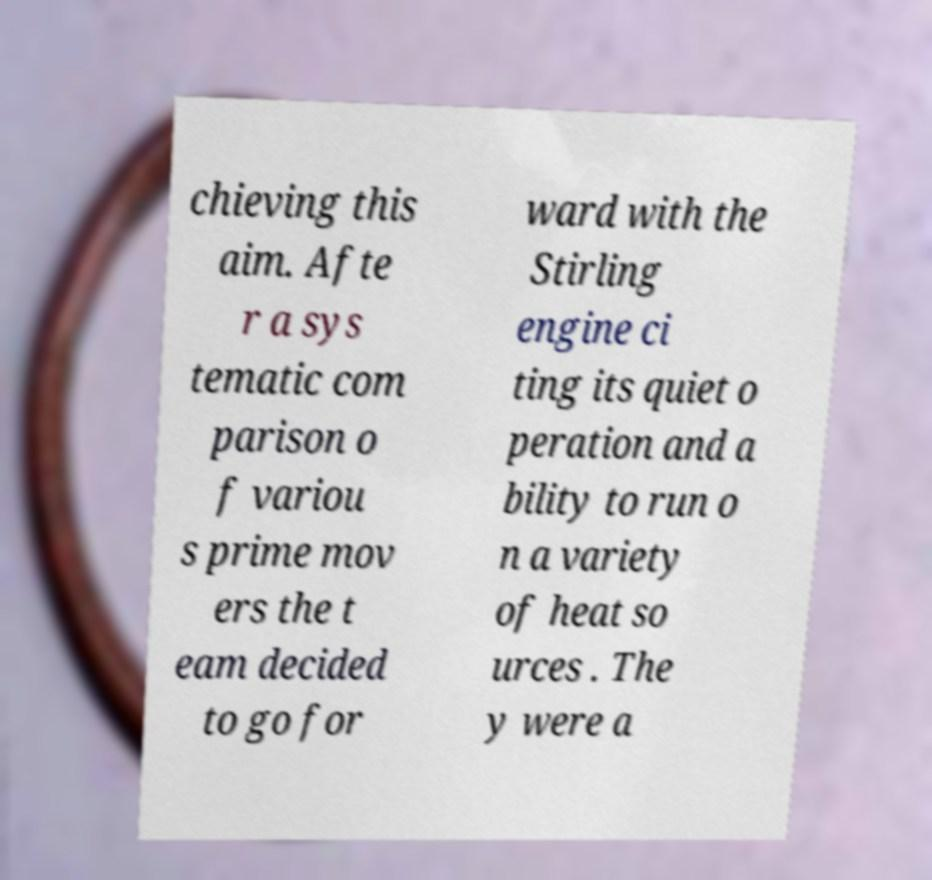Please read and relay the text visible in this image. What does it say? chieving this aim. Afte r a sys tematic com parison o f variou s prime mov ers the t eam decided to go for ward with the Stirling engine ci ting its quiet o peration and a bility to run o n a variety of heat so urces . The y were a 